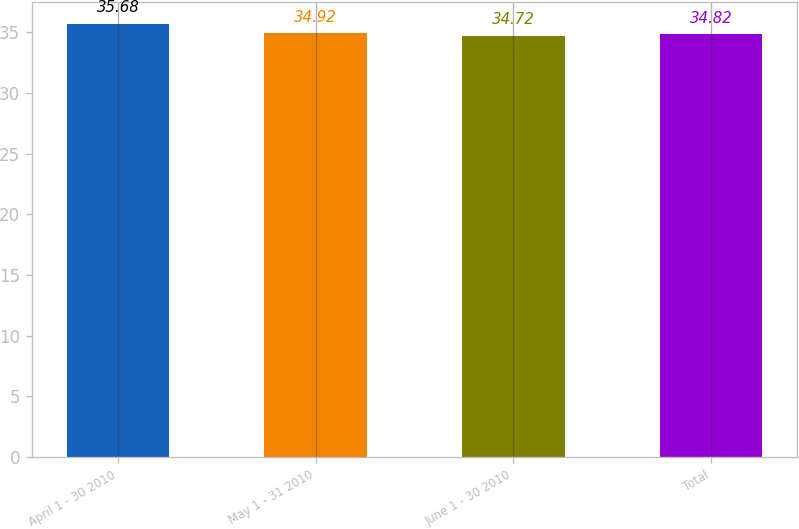Convert chart to OTSL. <chart><loc_0><loc_0><loc_500><loc_500><bar_chart><fcel>April 1 - 30 2010<fcel>May 1 - 31 2010<fcel>June 1 - 30 2010<fcel>Total<nl><fcel>35.68<fcel>34.92<fcel>34.72<fcel>34.82<nl></chart> 